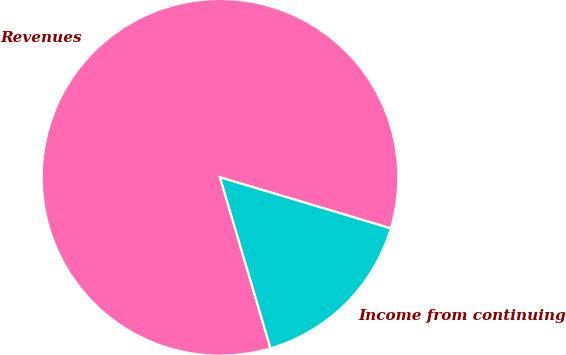Convert chart to OTSL. <chart><loc_0><loc_0><loc_500><loc_500><pie_chart><fcel>Revenues<fcel>Income from continuing<nl><fcel>84.2%<fcel>15.8%<nl></chart> 